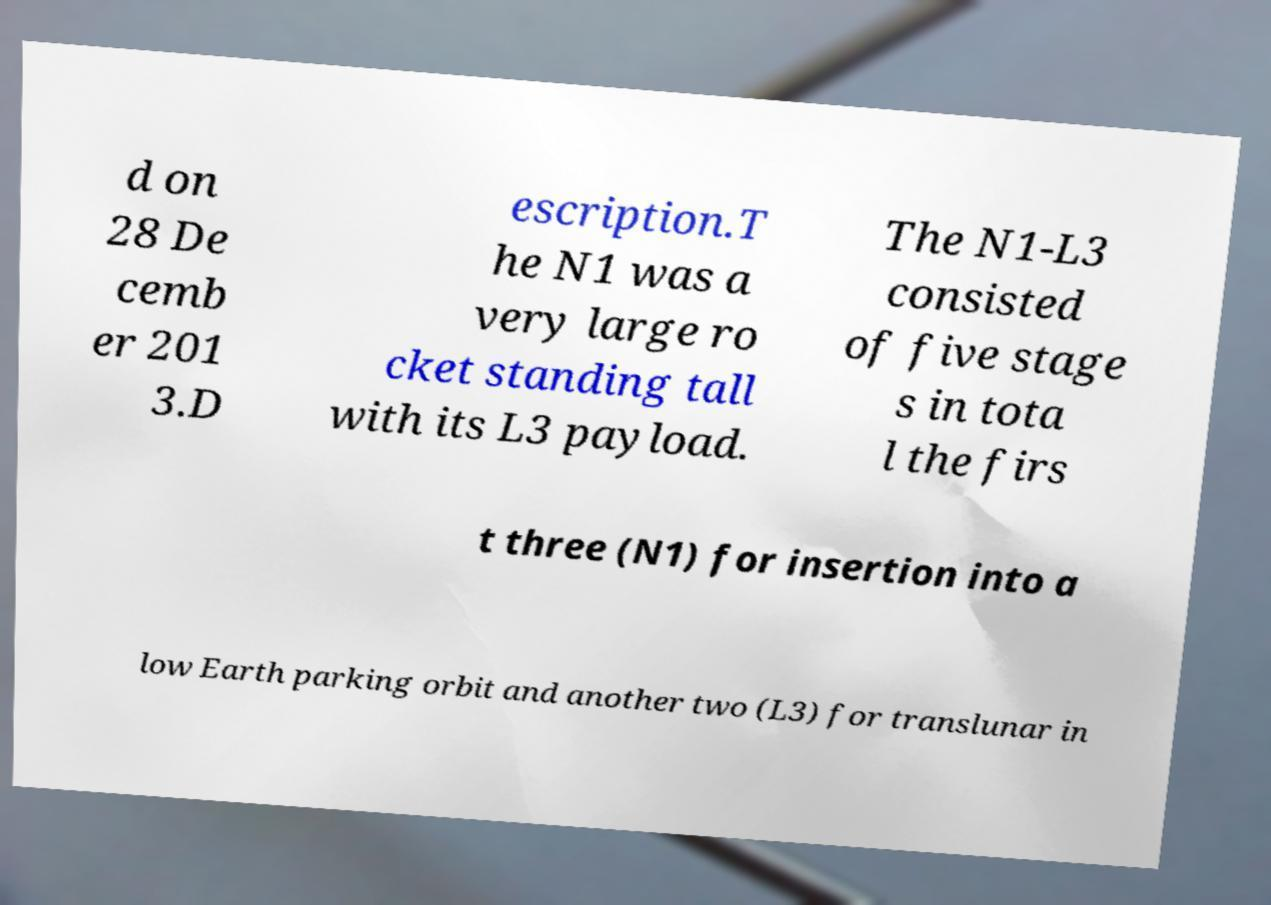Could you assist in decoding the text presented in this image and type it out clearly? d on 28 De cemb er 201 3.D escription.T he N1 was a very large ro cket standing tall with its L3 payload. The N1-L3 consisted of five stage s in tota l the firs t three (N1) for insertion into a low Earth parking orbit and another two (L3) for translunar in 